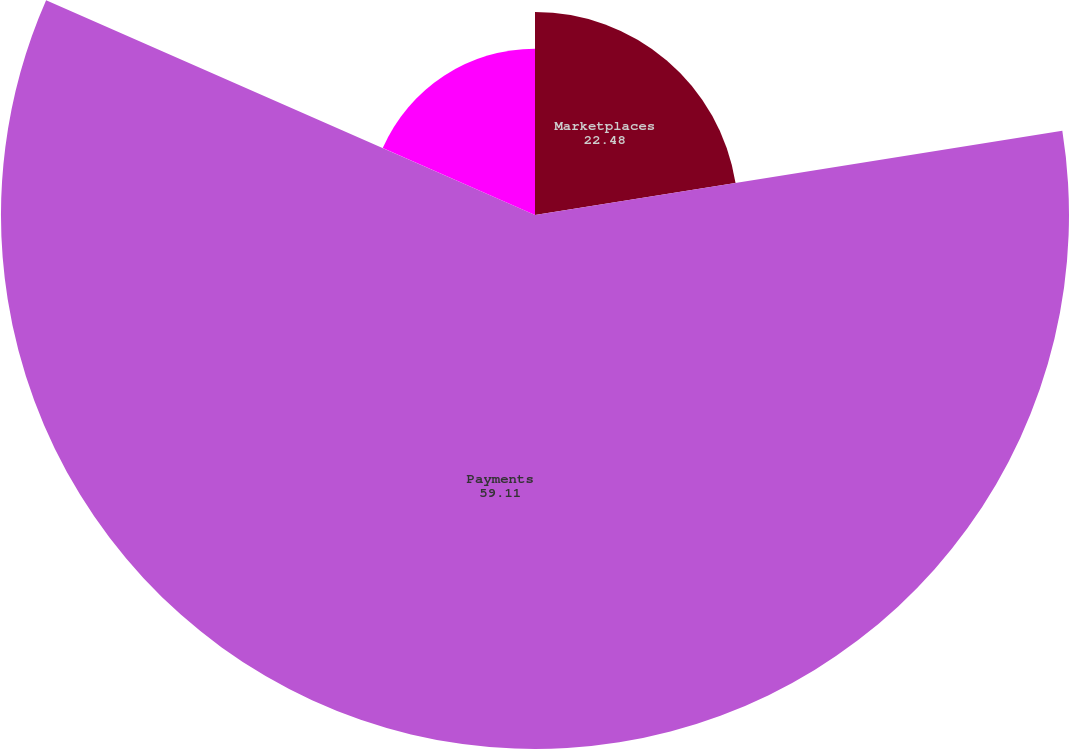<chart> <loc_0><loc_0><loc_500><loc_500><pie_chart><fcel>Marketplaces<fcel>Payments<fcel>Total cost of net revenues<nl><fcel>22.48%<fcel>59.11%<fcel>18.41%<nl></chart> 